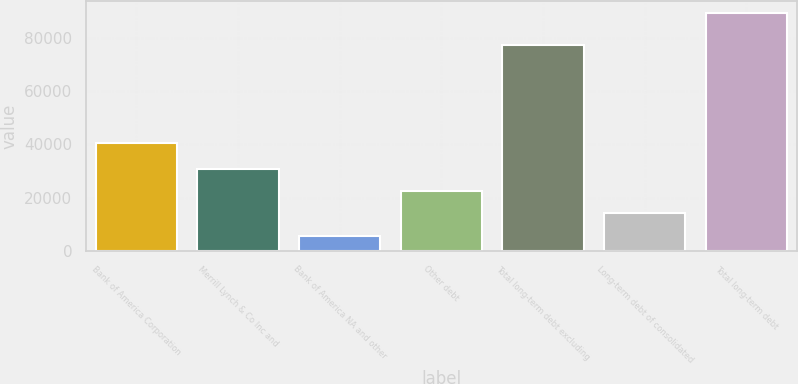<chart> <loc_0><loc_0><loc_500><loc_500><bar_chart><fcel>Bank of America Corporation<fcel>Merrill Lynch & Co Inc and<fcel>Bank of America NA and other<fcel>Other debt<fcel>Total long-term debt excluding<fcel>Long-term debt of consolidated<fcel>Total long-term debt<nl><fcel>40432<fcel>30813.6<fcel>5796<fcel>22474.4<fcel>77388<fcel>14135.2<fcel>89188<nl></chart> 